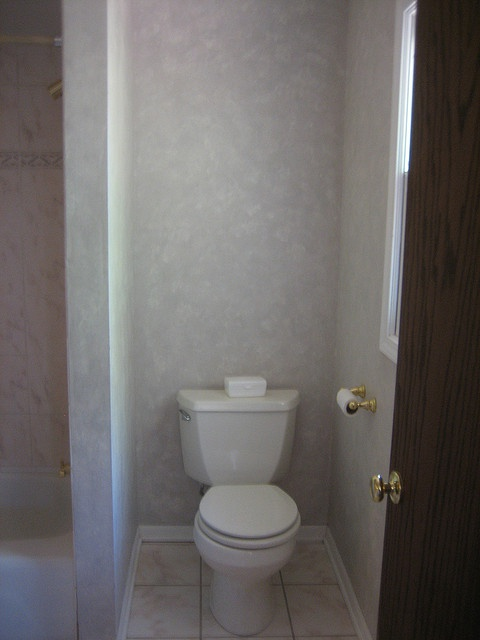Describe the objects in this image and their specific colors. I can see a toilet in black and gray tones in this image. 